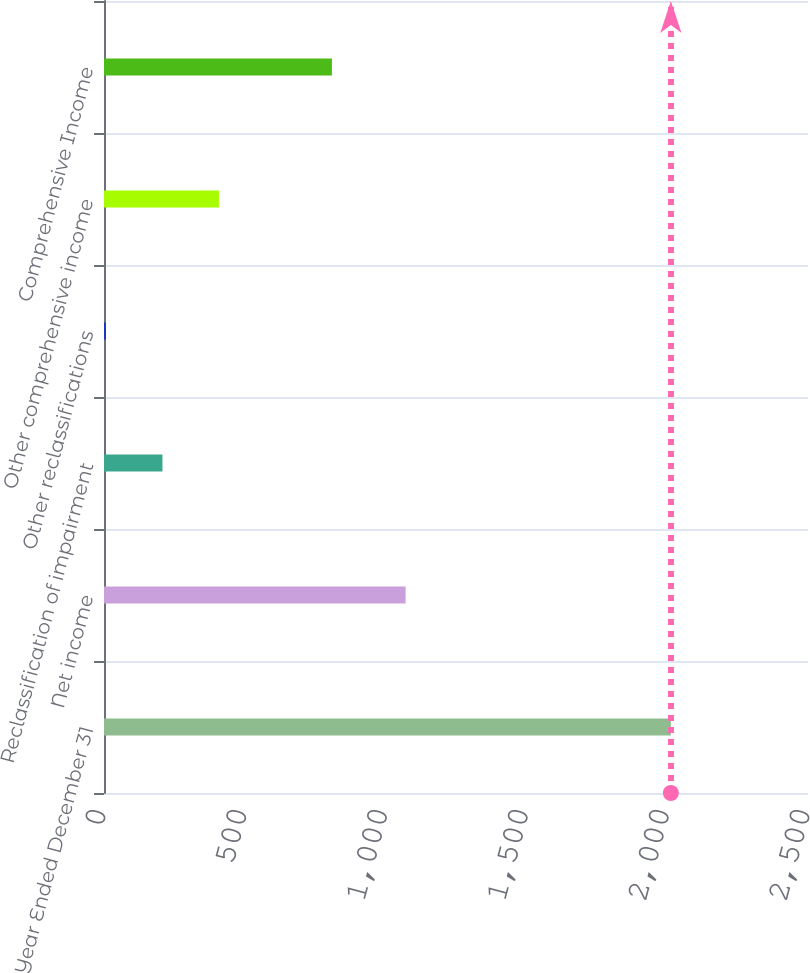<chart> <loc_0><loc_0><loc_500><loc_500><bar_chart><fcel>Year Ended December 31<fcel>Net income<fcel>Reclassification of impairment<fcel>Other reclassifications<fcel>Other comprehensive income<fcel>Comprehensive Income<nl><fcel>2013<fcel>1071<fcel>207.6<fcel>7<fcel>408.2<fcel>809.4<nl></chart> 